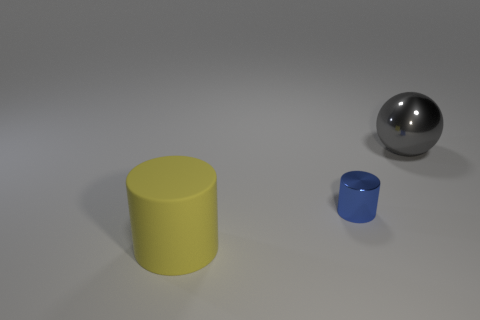Are there any blue shiny objects on the left side of the small blue metal thing?
Make the answer very short. No. There is another yellow thing that is the same shape as the tiny object; what is its size?
Keep it short and to the point. Large. Is there any other thing that has the same size as the blue thing?
Your answer should be very brief. No. Is the tiny blue metallic thing the same shape as the large shiny thing?
Ensure brevity in your answer.  No. There is a metallic object to the right of the cylinder that is behind the big yellow matte object; what size is it?
Make the answer very short. Large. There is another matte object that is the same shape as the small blue thing; what color is it?
Give a very brief answer. Yellow. How many small shiny cylinders are the same color as the small shiny thing?
Ensure brevity in your answer.  0. What size is the yellow object?
Ensure brevity in your answer.  Large. Is the shiny ball the same size as the blue metallic object?
Give a very brief answer. No. There is a thing that is in front of the large gray object and behind the big rubber cylinder; what is its color?
Give a very brief answer. Blue. 